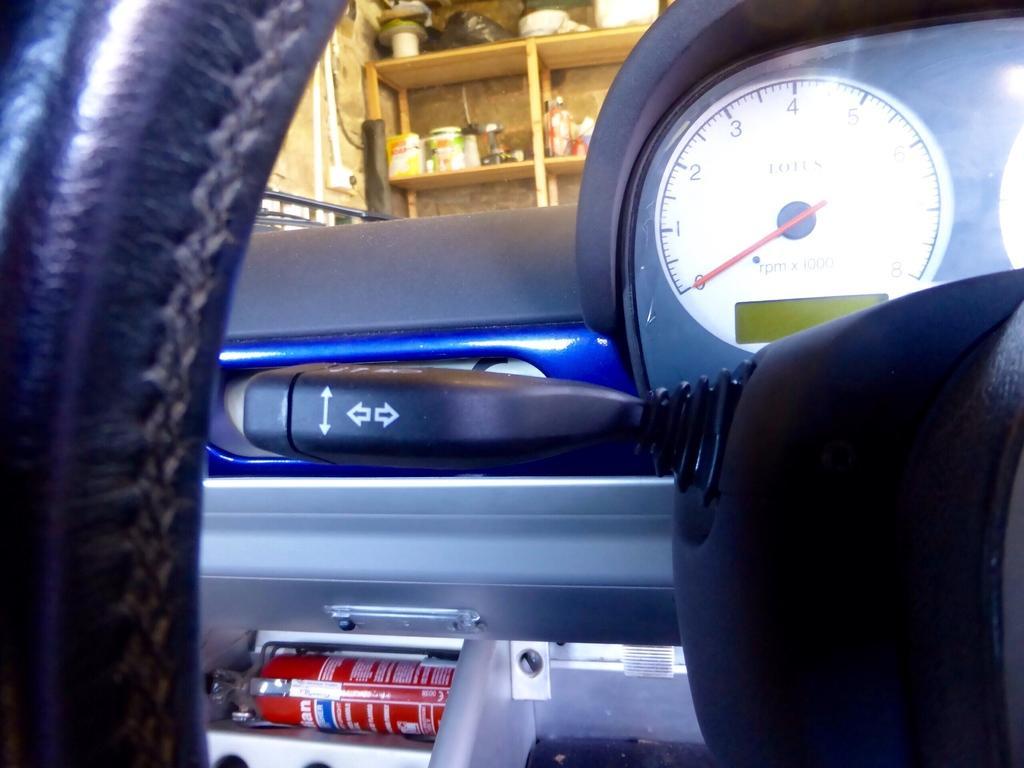How would you summarize this image in a sentence or two? In this picture we can observe a steering which is in black color. There is a meter which is in white color. In the background we can observe a shelf in which some jars are placed. We can observe a wall which is in cream color. 